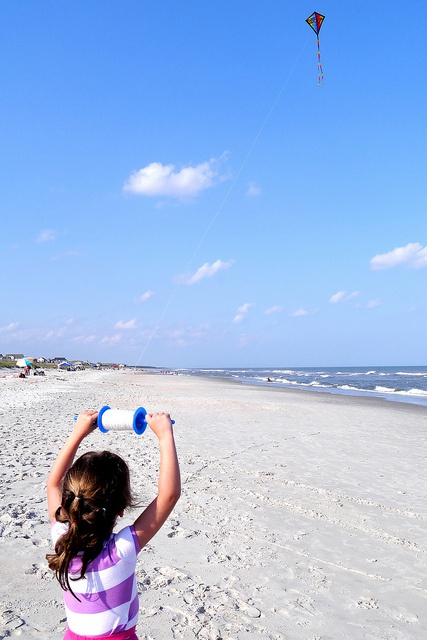Describe the objects in this image and their specific colors. I can see people in lightblue, black, white, maroon, and violet tones, kite in lightblue, black, maroon, and blue tones, people in lightblue, pink, black, lightpink, and maroon tones, people in lightblue, darkgray, gray, and lightpink tones, and people in lightblue, darkgray, gray, and navy tones in this image. 